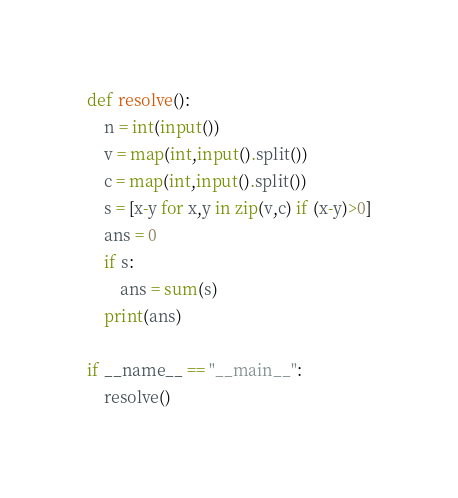Convert code to text. <code><loc_0><loc_0><loc_500><loc_500><_Python_>def resolve():
    n = int(input())
    v = map(int,input().split())
    c = map(int,input().split())
    s = [x-y for x,y in zip(v,c) if (x-y)>0]
    ans = 0
    if s:
        ans = sum(s)
    print(ans)

if __name__ == "__main__":
    resolve()</code> 